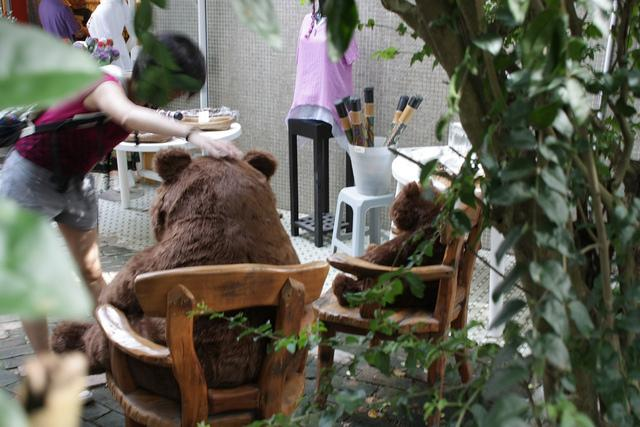How many bears are there?

Choices:
A) two
B) twenty
C) three
D) none two 